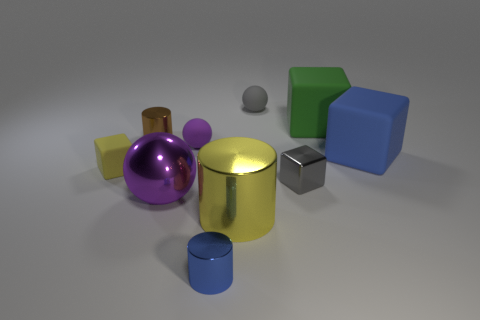Subtract all blue cylinders. How many cylinders are left? 2 Subtract all yellow cylinders. How many cylinders are left? 2 Subtract 2 cubes. How many cubes are left? 2 Add 6 gray shiny cubes. How many gray shiny cubes are left? 7 Add 4 green matte cubes. How many green matte cubes exist? 5 Subtract 0 purple cylinders. How many objects are left? 10 Subtract all blocks. How many objects are left? 6 Subtract all cyan spheres. Subtract all cyan cylinders. How many spheres are left? 3 Subtract all purple spheres. How many purple cylinders are left? 0 Subtract all large yellow cubes. Subtract all yellow metallic things. How many objects are left? 9 